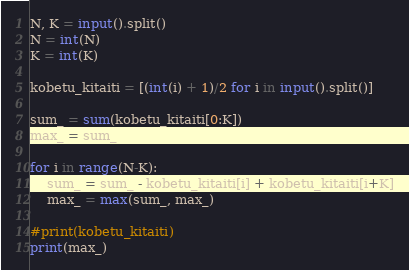Convert code to text. <code><loc_0><loc_0><loc_500><loc_500><_Python_>N, K = input().split()
N = int(N)
K = int(K)

kobetu_kitaiti = [(int(i) + 1)/2 for i in input().split()]

sum_ = sum(kobetu_kitaiti[0:K])
max_ = sum_

for i in range(N-K):
    sum_ = sum_ - kobetu_kitaiti[i] + kobetu_kitaiti[i+K]
    max_ = max(sum_, max_)

#print(kobetu_kitaiti)
print(max_)</code> 